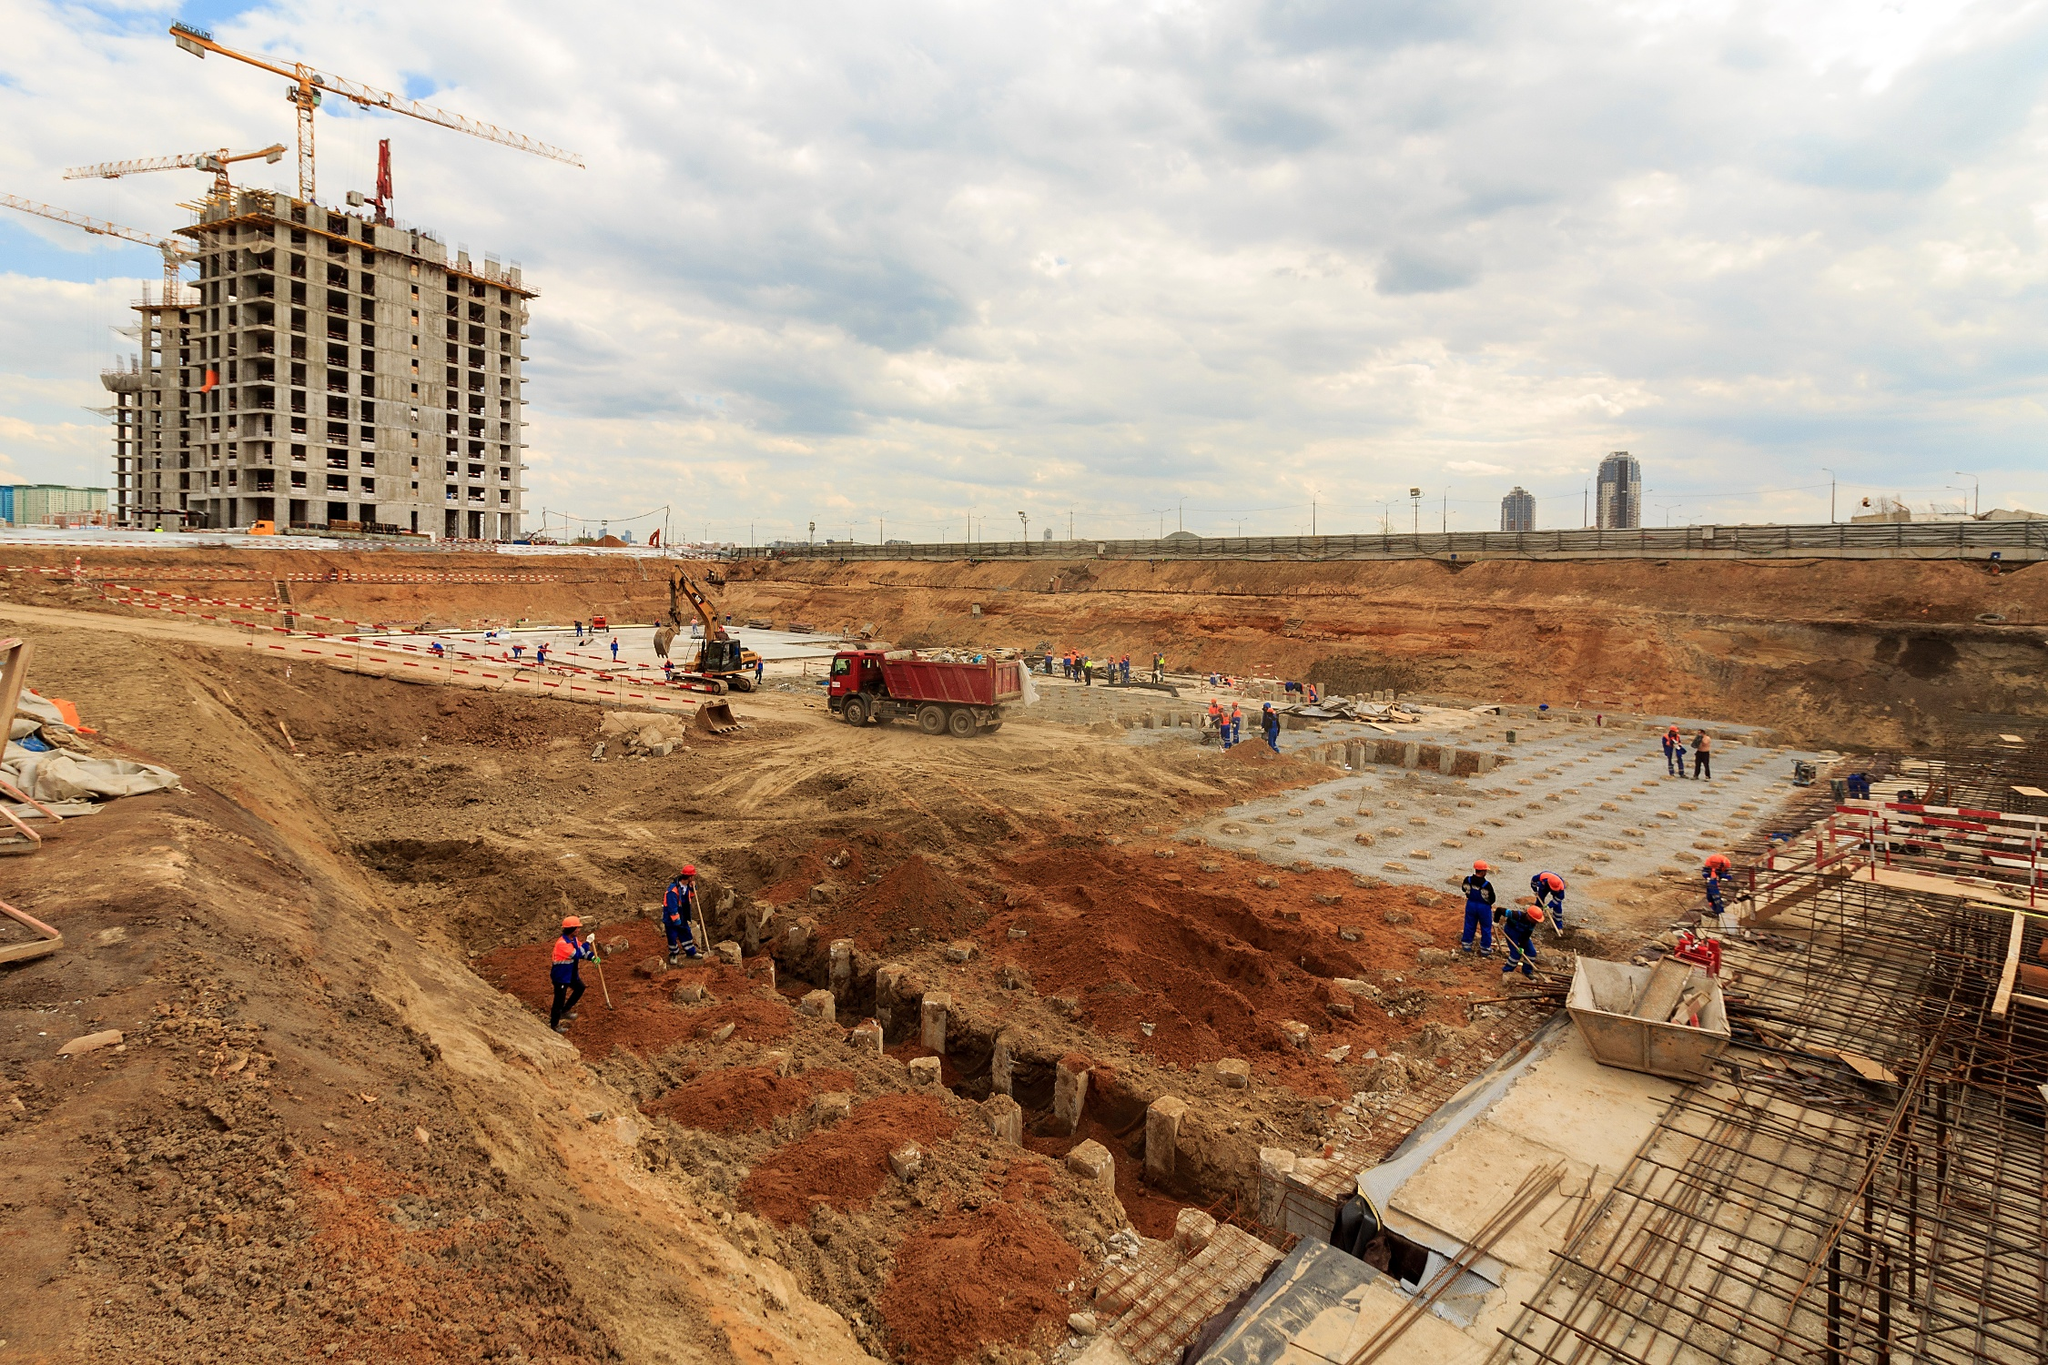What would be the historical significance if this construction site was part of an ancient civilization? If this site belonged to an ancient civilization, it would hold significant historical value as a testament to early engineering prowess and societal developments. The early construction techniques, the communal effort displayed by the workers, and the ambition of erecting tall structures would speak volumes about the civilization's capabilities and aspirations. Excavations and studies of such a site would provide insights into ancient building materials, labor organization, and the architectural ingenuity that laid the groundwork for modern construction practices.  Let's say the building under construction is a futuristic research facility. What kind of innovations might it bring? In this futuristic research facility, cutting-edge innovations are bound to emerge. Imagine breakthroughs in renewable energy harnessing, where the entire building is powered by solar panels integrated into its design. Inside, labs dedicated to advanced robotics could create autonomous machines capable of transforming construction industries. Genetic research might lead to revolutionary medical treatments or even enhancement of human health and abilities. The facility itself could be a model of sustainable architecture, using self-healing materials and advanced AI systems to maintain optimal conditions and efficiency. Why is the construction process exciting and important for urban development? The construction process is pivotal for urban development as it is the foundation of city expansion and modernization. Each new building contributes to economic growth by creating jobs and stimulating local businesses. Construction also introduces new infrastructure, enhancing living standards and urban functionality. For architects and engineers, it's an opportunity to innovate and implement sustainable practices that can lead to more eco-friendly cities. Moreover, new structures can breathe life into previously underdeveloped areas, transforming them into vibrant, productive parts of the city. 